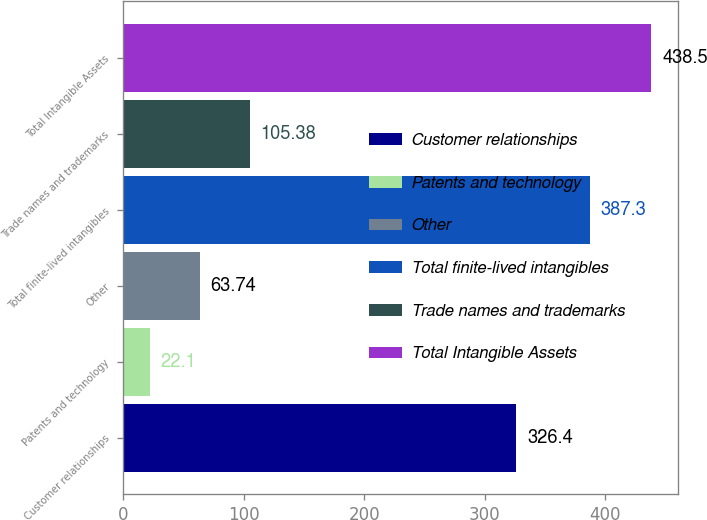Convert chart. <chart><loc_0><loc_0><loc_500><loc_500><bar_chart><fcel>Customer relationships<fcel>Patents and technology<fcel>Other<fcel>Total finite-lived intangibles<fcel>Trade names and trademarks<fcel>Total Intangible Assets<nl><fcel>326.4<fcel>22.1<fcel>63.74<fcel>387.3<fcel>105.38<fcel>438.5<nl></chart> 